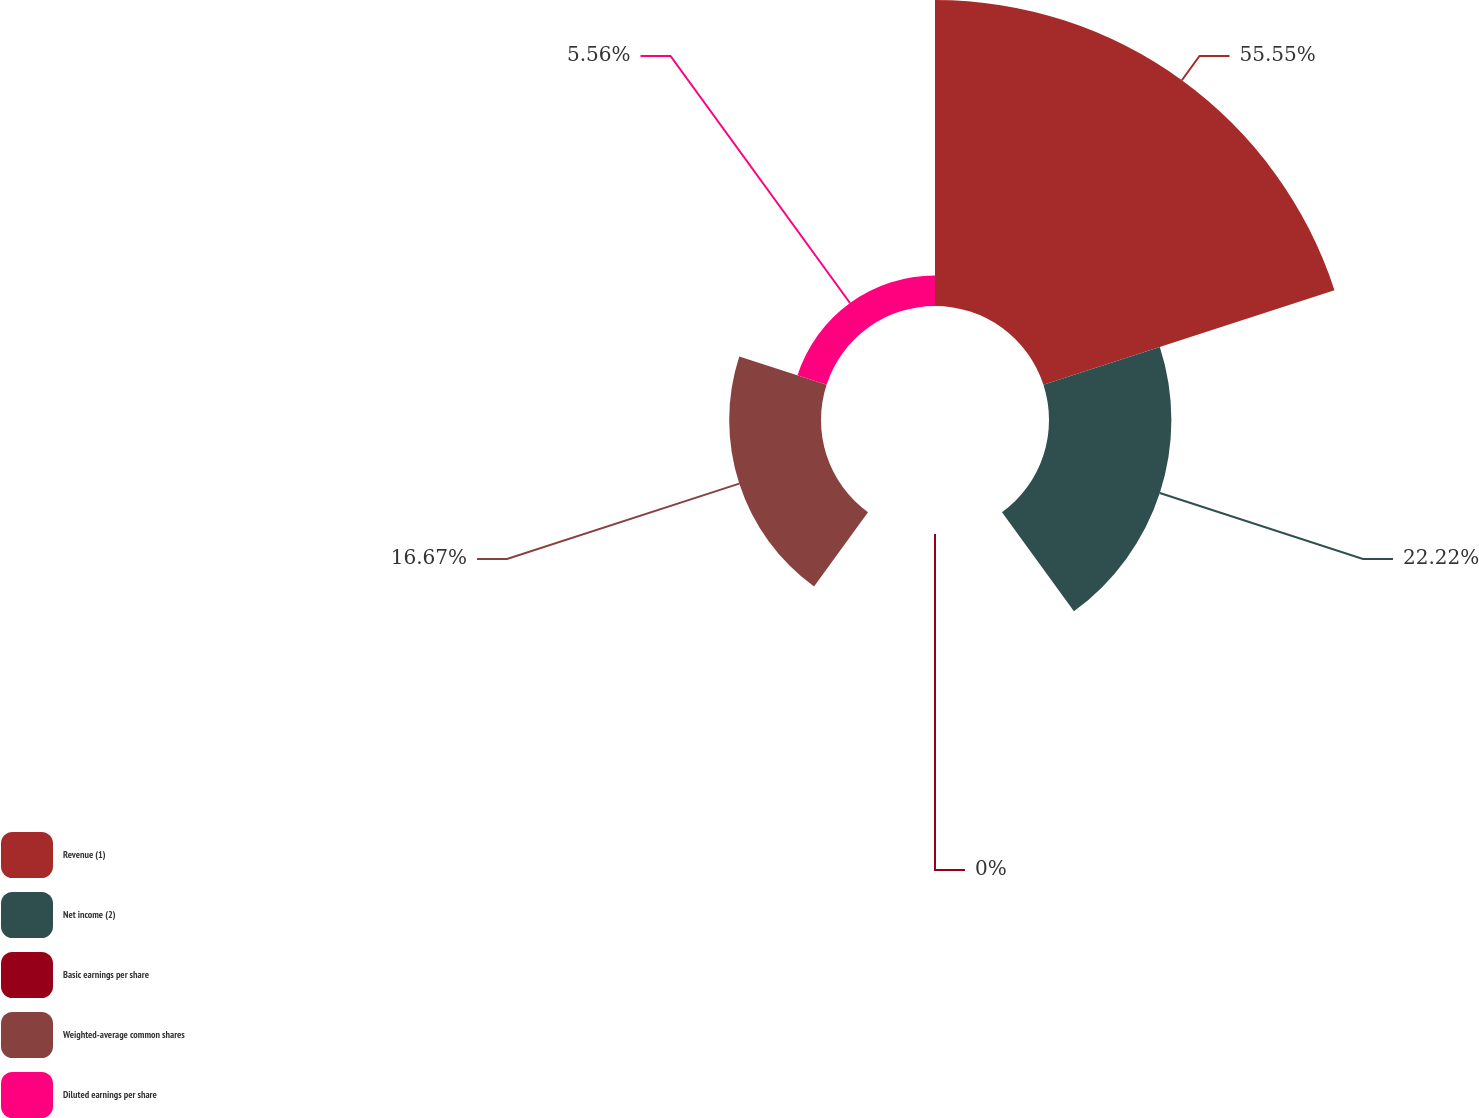Convert chart to OTSL. <chart><loc_0><loc_0><loc_500><loc_500><pie_chart><fcel>Revenue (1)<fcel>Net income (2)<fcel>Basic earnings per share<fcel>Weighted-average common shares<fcel>Diluted earnings per share<nl><fcel>55.56%<fcel>22.22%<fcel>0.0%<fcel>16.67%<fcel>5.56%<nl></chart> 